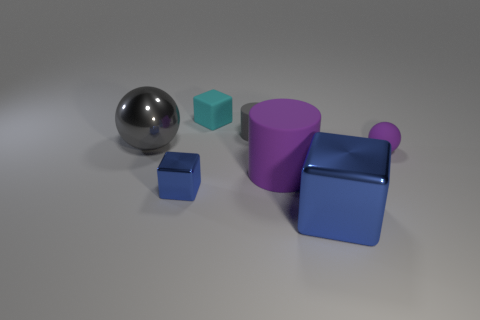What number of other things are the same color as the tiny cylinder?
Keep it short and to the point. 1. Is the number of big rubber cylinders greater than the number of big objects?
Offer a very short reply. No. What is the large blue cube made of?
Your response must be concise. Metal. There is a metallic block right of the cyan object; is its size the same as the big matte thing?
Offer a very short reply. Yes. What size is the rubber cylinder in front of the big gray shiny ball?
Ensure brevity in your answer.  Large. How many green metallic things are there?
Offer a terse response. 0. Do the small cylinder and the large sphere have the same color?
Your answer should be compact. Yes. The block that is in front of the tiny cylinder and behind the big blue thing is what color?
Your answer should be very brief. Blue. Are there any blue cubes in front of the small purple matte ball?
Your answer should be compact. Yes. What number of small matte objects are right of the small rubber thing that is on the right side of the large metal cube?
Make the answer very short. 0. 